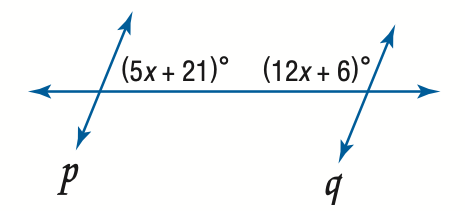Question: Find x so that p \parallel q.
Choices:
A. 2.1
B. 9
C. 12.2
D. 66
Answer with the letter. Answer: B 